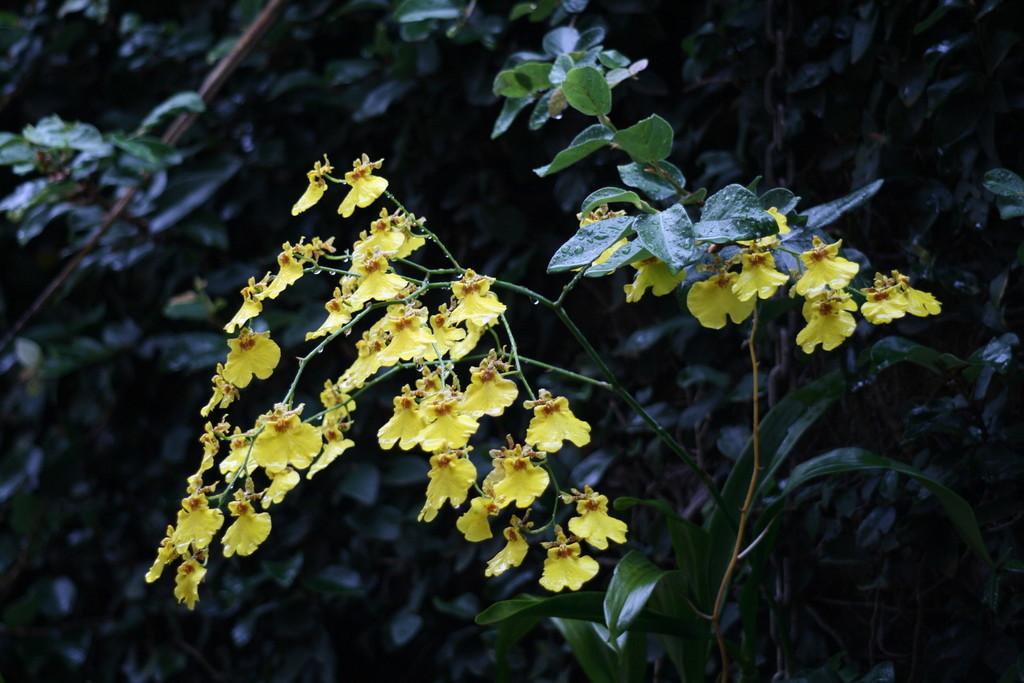In one or two sentences, can you explain what this image depicts? In the image we can see some flowers and trees. 